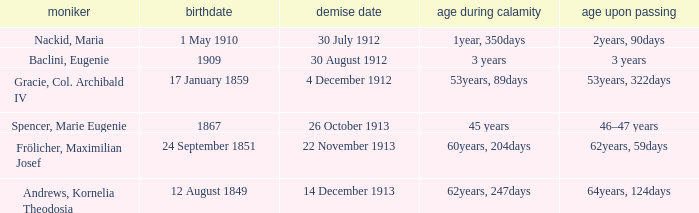What is the name of the person born in 1909? Baclini, Eugenie. 